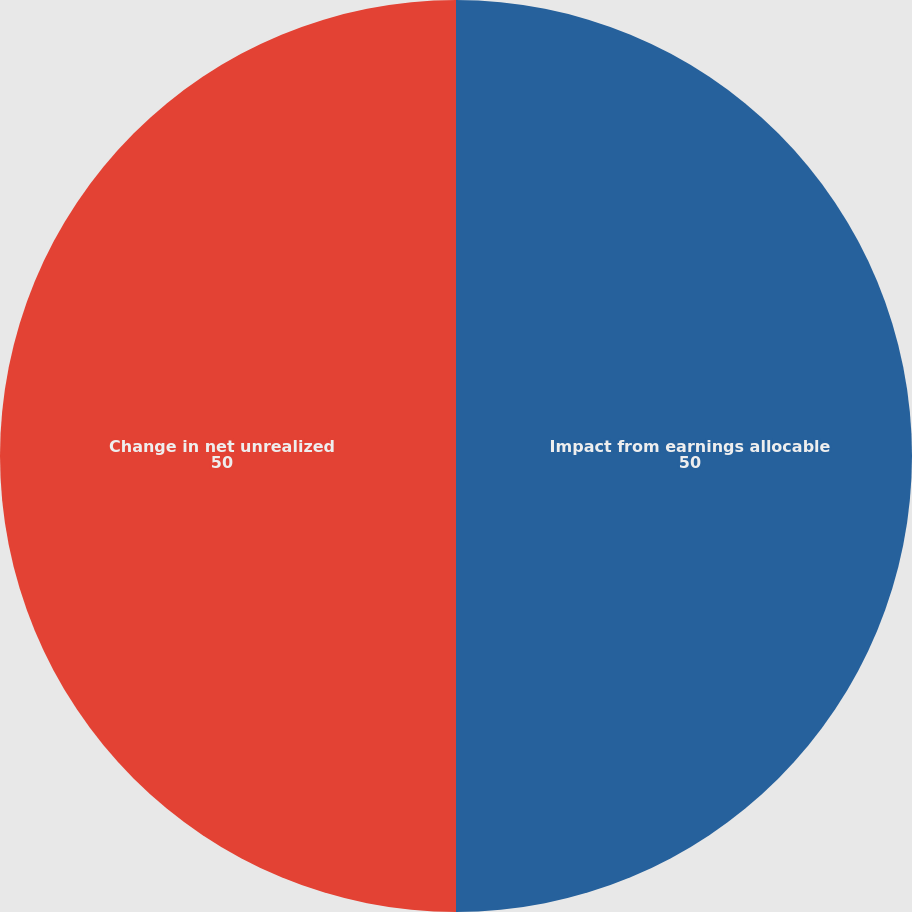Convert chart. <chart><loc_0><loc_0><loc_500><loc_500><pie_chart><fcel>Impact from earnings allocable<fcel>Change in net unrealized<nl><fcel>50.0%<fcel>50.0%<nl></chart> 